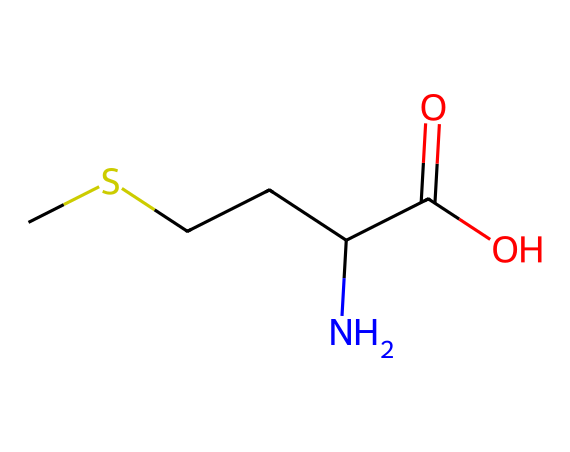What is the name of this chemical? The SMILES representation "CSCCC(N)C(=O)O" corresponds to methionine, which is an essential amino acid.
Answer: methionine How many carbon atoms are present in this structure? By analyzing the SMILES, there are four carbon atoms in the aliphatic chain and one in the carboxylic acid group, totaling five carbon atoms.
Answer: five Which functional groups are present in this molecule? The molecule has an amino group (-NH2) and a carboxylic acid group (-COOH), which are both present in amino acids.
Answer: amino and carboxylic acid What is the total number of hydrogen atoms in this compound? Each carbon balances with hydrogen atoms; by calculating the hydrogens connected to the carbons and taking into account the amino and carboxylic groups, there are 11 hydrogen atoms in total.
Answer: eleven What type of organosulfur compound is methionine? Methionine is classified as a sulfur-containing amino acid, as it contains a sulfur atom in its structure (notably in its side chain).
Answer: sulfur-containing amino acid How does the presence of sulfur affect the properties of methionine? The sulfur atom contributes to the characteristic properties such as enhancing protein function and influencing the structure of proteins, especially in disulfide bonds.
Answer: enhances protein function What is the significance of methionine in dietary sources? Methionine is vital for human health and is found in high-quality protein sources, contributing to various metabolic processes and the synthesis of other important compounds like cysteine.
Answer: essential nutrient 